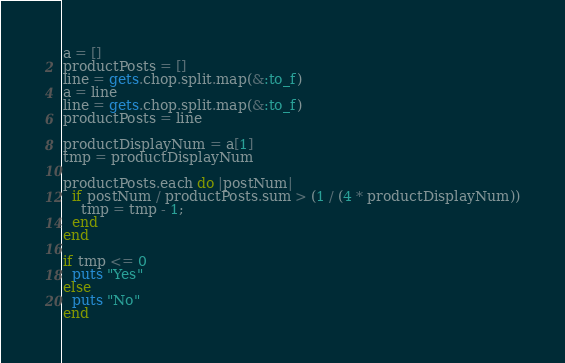Convert code to text. <code><loc_0><loc_0><loc_500><loc_500><_Ruby_>a = []
productPosts = []
line = gets.chop.split.map(&:to_f)
a = line
line = gets.chop.split.map(&:to_f)
productPosts = line

productDisplayNum = a[1]
tmp = productDisplayNum

productPosts.each do |postNum|
  if postNum / productPosts.sum > (1 / (4 * productDisplayNum))
    tmp = tmp - 1;
  end
end

if tmp <= 0
  puts "Yes"
else
  puts "No"
end
</code> 